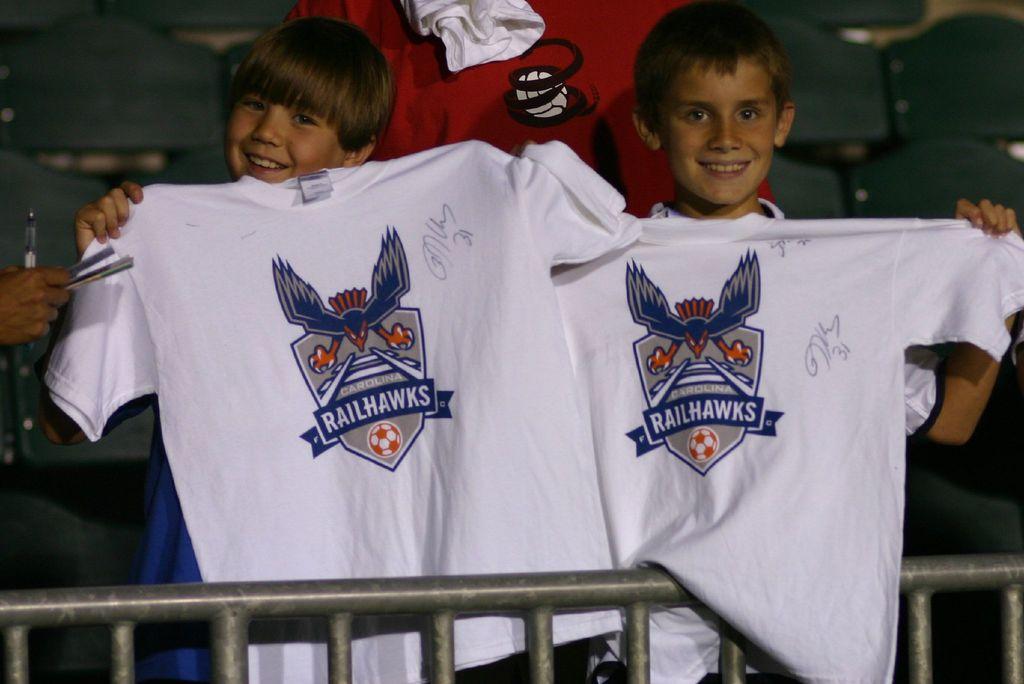What teams logo is on the shirt?
Your response must be concise. Railhawks. What state is shown on these tshirts?
Give a very brief answer. Carolina. 